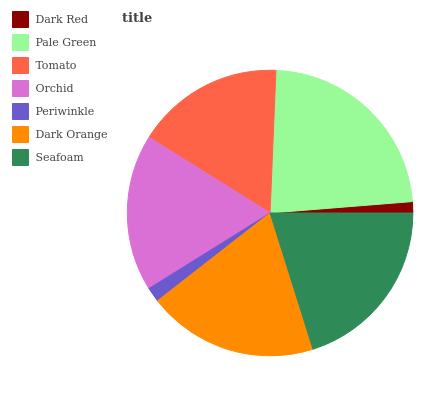Is Dark Red the minimum?
Answer yes or no. Yes. Is Pale Green the maximum?
Answer yes or no. Yes. Is Tomato the minimum?
Answer yes or no. No. Is Tomato the maximum?
Answer yes or no. No. Is Pale Green greater than Tomato?
Answer yes or no. Yes. Is Tomato less than Pale Green?
Answer yes or no. Yes. Is Tomato greater than Pale Green?
Answer yes or no. No. Is Pale Green less than Tomato?
Answer yes or no. No. Is Orchid the high median?
Answer yes or no. Yes. Is Orchid the low median?
Answer yes or no. Yes. Is Pale Green the high median?
Answer yes or no. No. Is Dark Orange the low median?
Answer yes or no. No. 